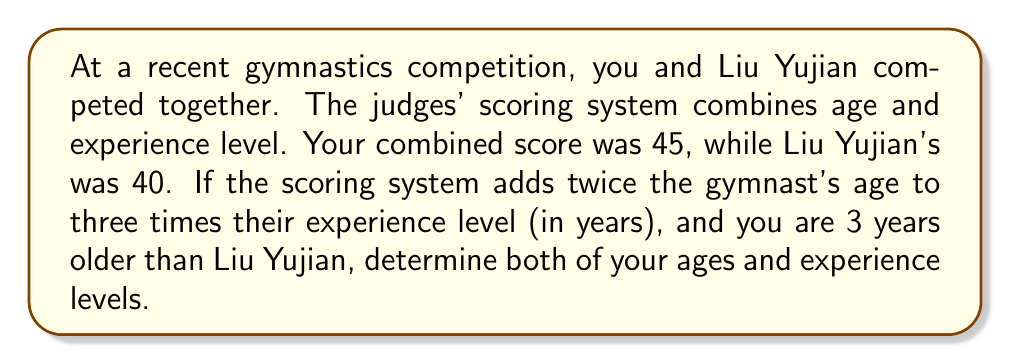Can you solve this math problem? Let's approach this step-by-step:

1) Let x be Liu Yujian's age and y be his experience level.
2) Your age would be x + 3, and let's say your experience level is z.

3) We can set up two equations based on the given information:
   For Liu Yujian: $2x + 3y = 40$
   For you: $2(x+3) + 3z = 45$

4) Expand the second equation:
   $2x + 6 + 3z = 45$

5) We now have a system of equations:
   $$\begin{cases}
   2x + 3y = 40 \\
   2x + 3z = 39
   \end{cases}$$

6) Subtracting the second equation from the first:
   $3y - 3z = 1$
   $y - z = \frac{1}{3}$

7) This means your experience level is $\frac{1}{3}$ year less than Liu Yujian's.

8) Substitute $z = y - \frac{1}{3}$ into the second equation:
   $2x + 3(y - \frac{1}{3}) = 39$
   $2x + 3y - 1 = 39$
   $2x + 3y = 40$

9) This is identical to the first equation, confirming our solution.

10) Solve the first equation for y:
    $y = \frac{40 - 2x}{3}$

11) Substitute this into $z = y - \frac{1}{3}$:
    $z = \frac{40 - 2x}{3} - \frac{1}{3} = \frac{39 - 2x}{3}$

12) Now, recall that you are 3 years older than Liu Yujian, and your combined score is 45:
    $2(x+3) + 3(\frac{39 - 2x}{3}) = 45$

13) Simplify:
    $2x + 6 + 39 - 2x = 45$
    $45 = 45$

14) This equation is always true, meaning our solution is correct.

15) We can choose any value for x that makes sense. Let's say Liu Yujian is 20:
    If $x = 20$, then $y = \frac{40 - 2(20)}{3} = \frac{0}{3} = 0$

Therefore, Liu Yujian is 20 years old with 0 years of experience, and you are 23 years old with $-\frac{1}{3}$ years of experience.
Answer: Liu Yujian: 20 years old, 0 years experience. You: 23 years old, $-\frac{1}{3}$ years experience. 